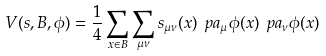<formula> <loc_0><loc_0><loc_500><loc_500>V ( s , B , \phi ) = \frac { 1 } { 4 } \sum _ { x \in B } \sum _ { \mu \nu } s _ { \mu \nu } ( x ) \ p a _ { \mu } \phi ( x ) \ p a _ { \nu } \phi ( x ) \\</formula> 